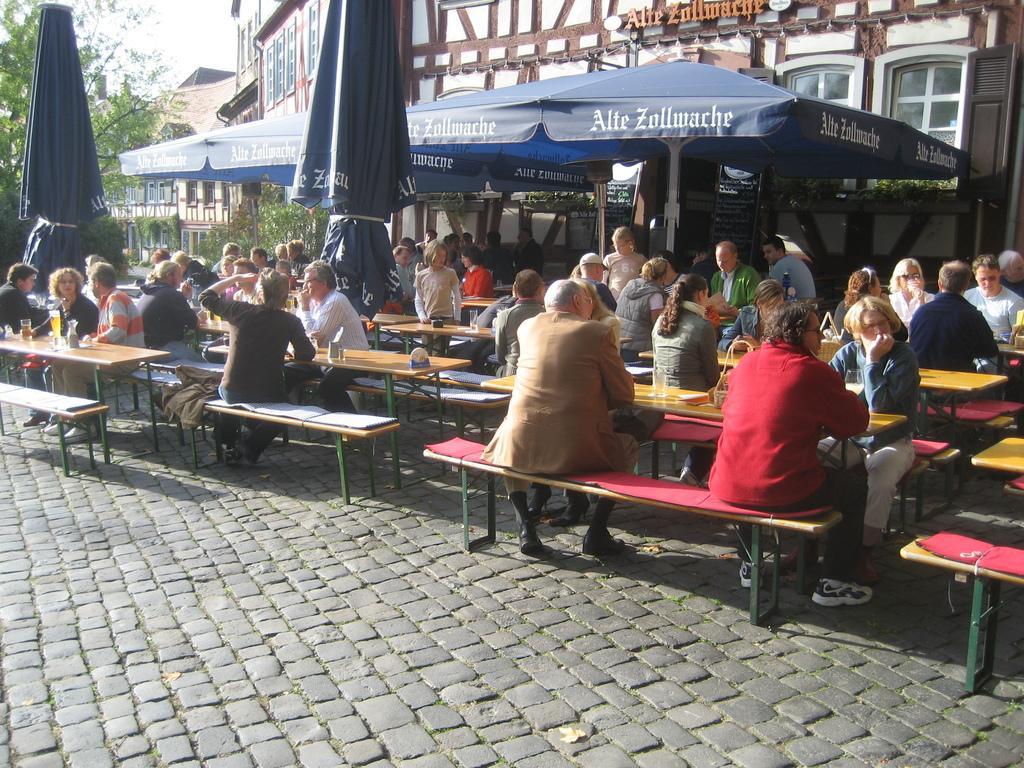Could you give a brief overview of what you see in this image? In this picture we can see a group of people sitting on benches and some are standing and in front of them on table we have glass, stand, bottle and in background we can see tent, building with windows, tree, sky, umbrella. 